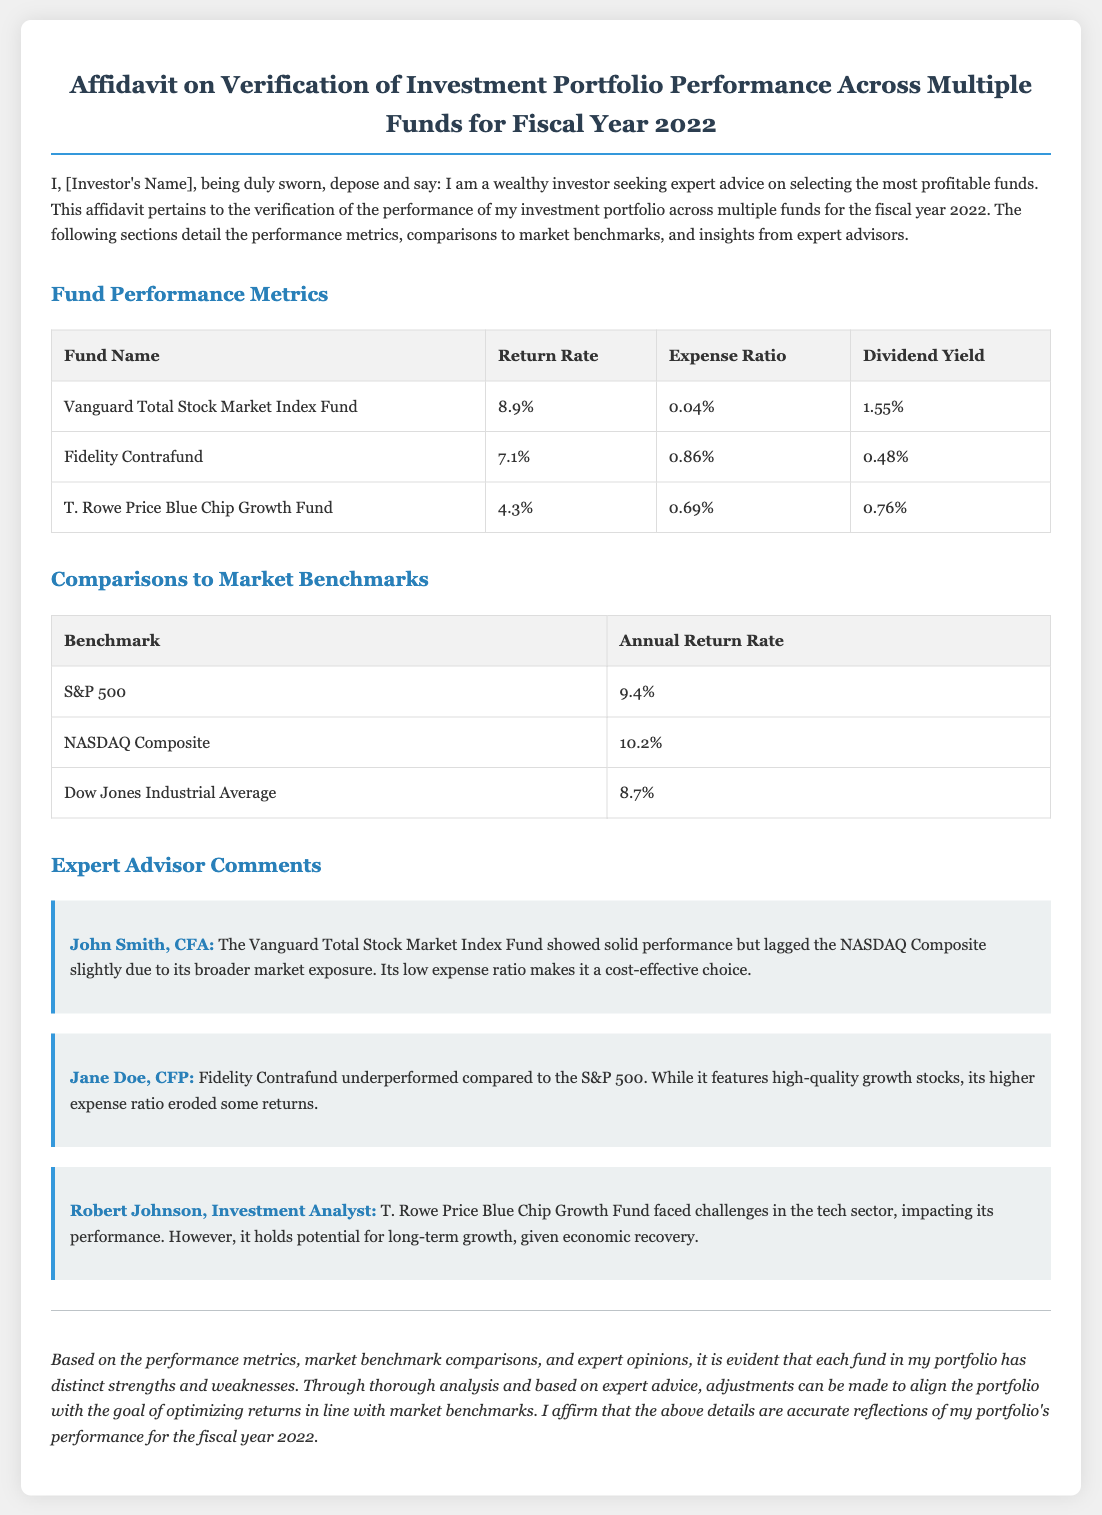what is the return rate of the Vanguard Total Stock Market Index Fund? The return rate of the Vanguard Total Stock Market Index Fund is detailed in the performance metrics table.
Answer: 8.9% what is the expense ratio of Fidelity Contrafund? The expense ratio of Fidelity Contrafund is presented in the performance metrics section.
Answer: 0.86% which benchmark had the highest annual return rate? The annual return rates of various benchmarks are compared in the benchmarks table. The highest is from NASDAQ Composite.
Answer: 10.2% what comment was made by John Smith, CFA? John Smith, CFA provided insights regarding the performance of the Vanguard Total Stock Market Index Fund.
Answer: The Vanguard Total Stock Market Index Fund showed solid performance but lagged the NASDAQ Composite slightly due to its broader market exposure how did the T. Rowe Price Blue Chip Growth Fund perform in fiscal year 2022? Expert comments provide insights about the T. Rowe Price Blue Chip Growth Fund's performance challenges.
Answer: Faced challenges in the tech sector what is the conclusion emphasized in the document? The conclusion summarizes the insights regarding the fund performances and recommendations for adjustments.
Answer: Adjustments can be made to align the portfolio with the goal of optimizing returns 